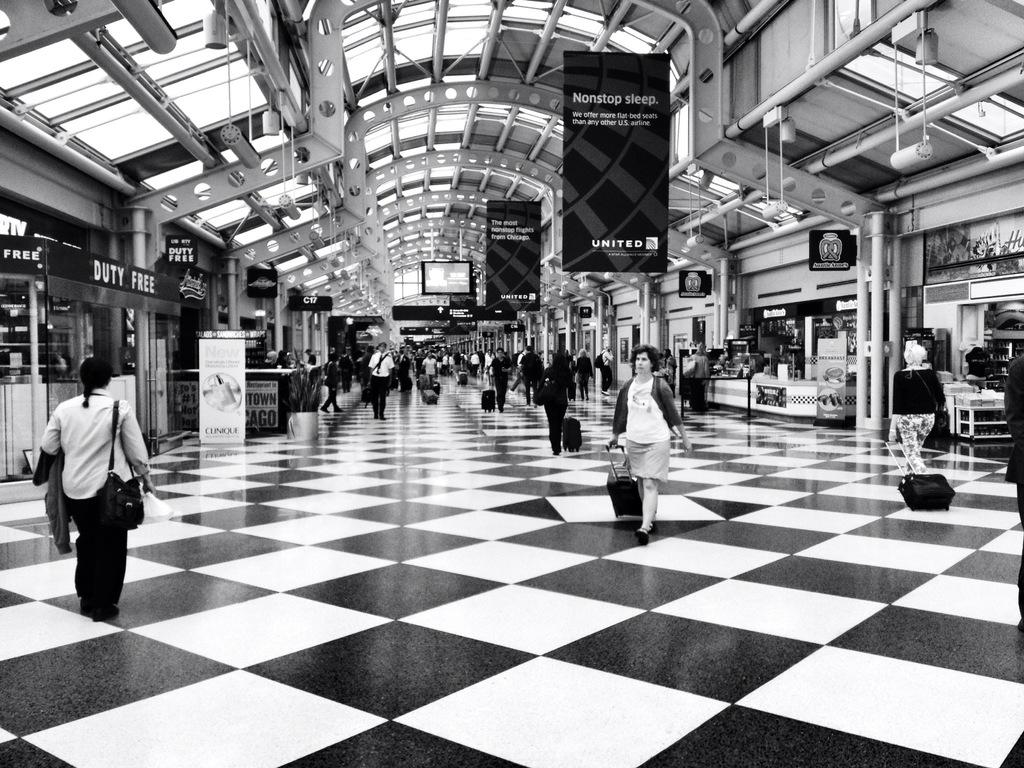What is happening inside the building in the image? There are people inside the building, and they are walking. What are the people holding in the image? The people are holding bags. What can be seen in the background of the image? There are shops with banners visible. What type of pies can be seen on the shelves in the image? There are no pies visible in the image; the focus is on the people walking and holding bags. 